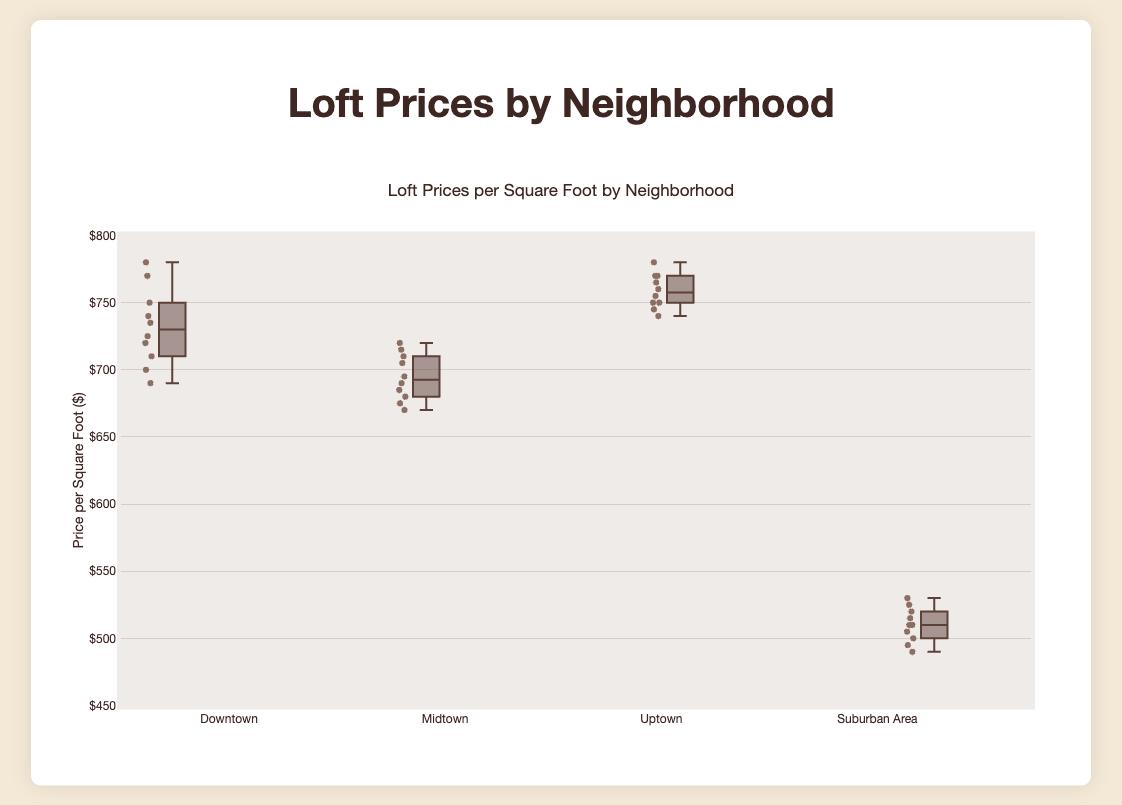What's the highest price per square foot in the Uptown neighborhood? To determine this, look at the end of the upper whisker or any outliers beyond it for Uptown.
Answer: 780 Which neighborhood has the lowest range in price per square foot? Check the length of the boxes and whiskers for each neighborhood. The shortest will indicate the lowest range.
Answer: Midtown What is the median price per square foot in the Downtown neighborhood? Find the line inside the Downtown's box; it represents the median value.
Answer: 735 How does the upper whisker of the Suburban Area compare to the lower whisker of Downtown? Observe the value at the end of Suburban Area’s upper whisker and Downtown’s lower whisker. Compare these two values.
Answer: Suburban Area's upper whisker is lower Which neighborhood has the highest median price per square foot? Look at the median lines in the boxes for each neighborhood and identify the highest one.
Answer: Uptown Is there any overlap in the price per square foot ranges between Downtown and Midtown? Check if the whiskers and possibly the boxes of these two neighborhoods overlap on the Y-axis.
Answer: Yes Which neighborhood has the widest interquartile range (IQR) for price per square foot? Determine the size of each box (from Q1 to Q3). The neighborhood with the largest box width has the widest IQR.
Answer: Downtown What is the difference in the median price per square foot between Downtown and Suburban Area? Subtract the median price of Suburban Area from the median price of Downtown.
Answer: 735 - 510 = 225 Are there any outliers in the Midtown neighborhood's price distribution? Look for any points outside the whiskers in Midtown’s box plot.
Answer: No Which neighborhood shows the most variability in price per square foot? Assess the total range (including outliers, whiskers, and box width) for each neighborhood. The neighborhood with the largest overall spread shows the most variability.
Answer: Uptown 